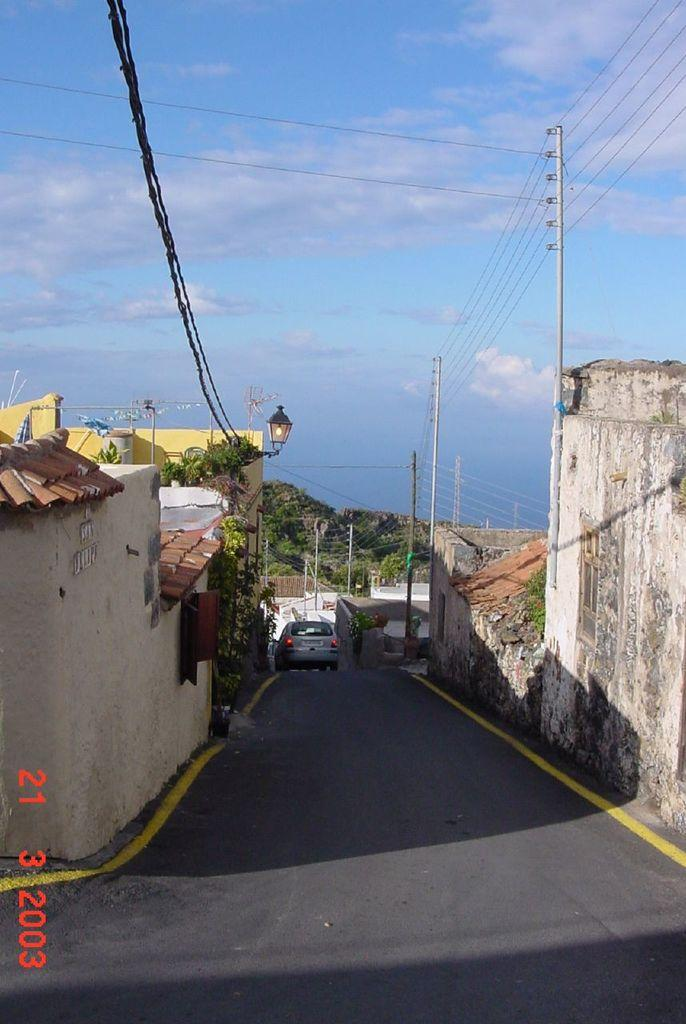What is the main subject of the image? The main subject of the image is a vehicle. What is the vehicle doing in the image? The vehicle is moving on the road. What can be seen in the background beside the road in the image? There are houses visible beside the road in the image. Can you tell me how many whips are being used by the dad in the image? There is no dad or whip present in the image. What type of crook is visible in the image? There is no crook present in the image. 